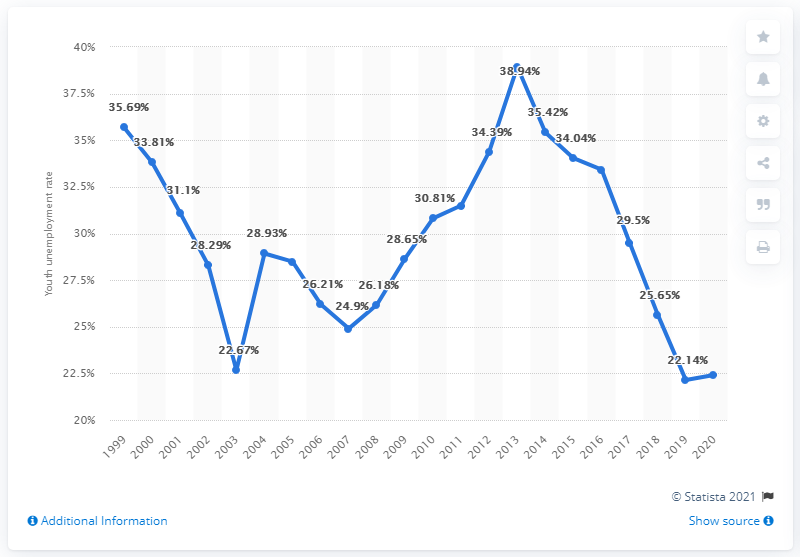Highlight a few significant elements in this photo. In 2020, the youth unemployment rate in Jamaica was 22.41%. 